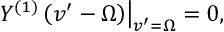<formula> <loc_0><loc_0><loc_500><loc_500>Y ^ { ( 1 ) } \left ( v ^ { \prime } - \Omega \right ) \right | _ { v ^ { \prime } = \Omega } = 0 ,</formula> 